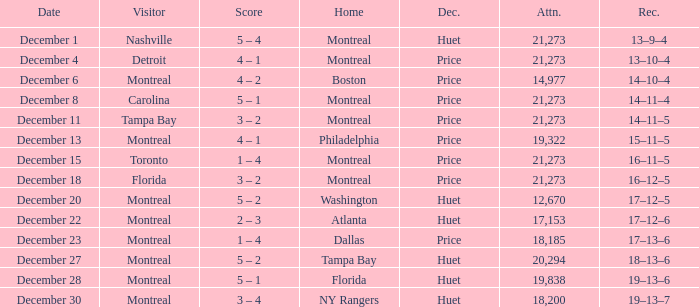What is the score when Philadelphia is at home? 4 – 1. 